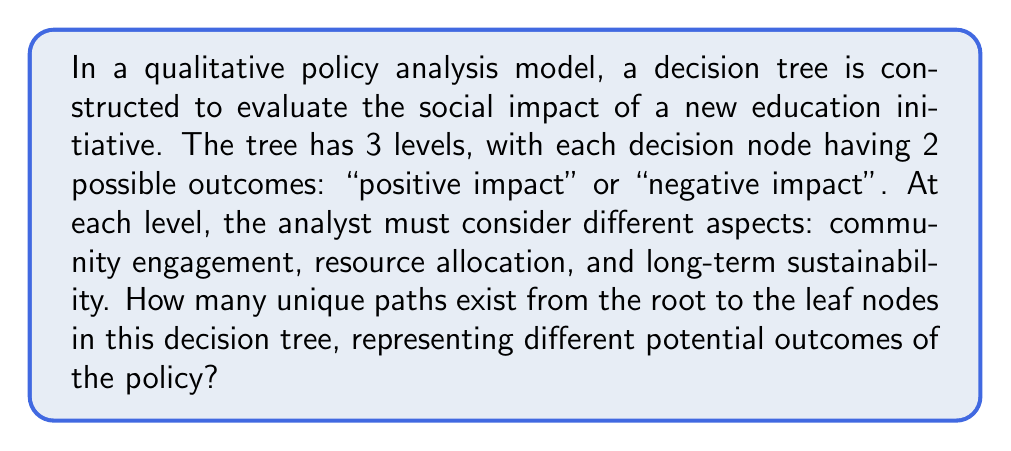Provide a solution to this math problem. Let's approach this step-by-step, considering the qualitative nature of the analysis:

1) First, we need to understand the structure of the decision tree:
   - It has 3 levels
   - Each node has 2 possible outcomes

2) At each level, we make a binary choice (positive or negative impact):
   - Level 1 (Community Engagement): 2 choices
   - Level 2 (Resource Allocation): 2 choices for each outcome of level 1
   - Level 3 (Long-term Sustainability): 2 choices for each outcome of level 2

3) To find the total number of unique paths, we multiply the number of choices at each level:

   $$ \text{Total Paths} = 2 \times 2 \times 2 = 2^3 $$

4) This can be generalized as:

   $$ \text{Total Paths} = 2^n $$

   Where $n$ is the number of levels in the decision tree.

5) In this case, with 3 levels:

   $$ \text{Total Paths} = 2^3 = 8 $$

Each of these 8 paths represents a unique combination of outcomes across the three aspects of the policy analysis, providing a comprehensive view of possible scenarios without relying solely on quantitative metrics.
Answer: 8 unique paths 